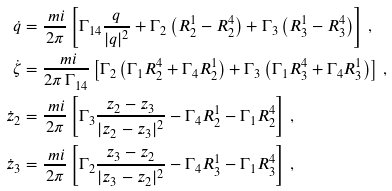Convert formula to latex. <formula><loc_0><loc_0><loc_500><loc_500>\dot { q } & = \frac { \ m i } { 2 \pi } \left [ \Gamma _ { 1 4 } \frac { q } { | q | ^ { 2 } } + \Gamma _ { 2 } \left ( R _ { 2 } ^ { 1 } - R _ { 2 } ^ { 4 } \right ) + \Gamma _ { 3 } \left ( R _ { 3 } ^ { 1 } - R _ { 3 } ^ { 4 } \right ) \right ] \, , \\ \dot { \zeta } & = \frac { \ m i } { 2 \pi \, \Gamma _ { 1 4 } } \left [ \Gamma _ { 2 } \left ( \Gamma _ { 1 } R _ { 2 } ^ { 4 } + \Gamma _ { 4 } R _ { 2 } ^ { 1 } \right ) + \Gamma _ { 3 } \left ( \Gamma _ { 1 } R _ { 3 } ^ { 4 } + \Gamma _ { 4 } R _ { 3 } ^ { 1 } \right ) \right ] \, , \\ \dot { z } _ { 2 } & = \frac { \ m i } { 2 \pi } \left [ \Gamma _ { 3 } \frac { z _ { 2 } - z _ { 3 } } { | z _ { 2 } - z _ { 3 } | ^ { 2 } } - \Gamma _ { 4 } R _ { 2 } ^ { 1 } - \Gamma _ { 1 } R _ { 2 } ^ { 4 } \right ] \, , \\ \dot { z } _ { 3 } & = \frac { \ m i } { 2 \pi } \left [ \Gamma _ { 2 } \frac { z _ { 3 } - z _ { 2 } } { | z _ { 3 } - z _ { 2 } | ^ { 2 } } - \Gamma _ { 4 } R _ { 3 } ^ { 1 } - \Gamma _ { 1 } R _ { 3 } ^ { 4 } \right ] \, ,</formula> 